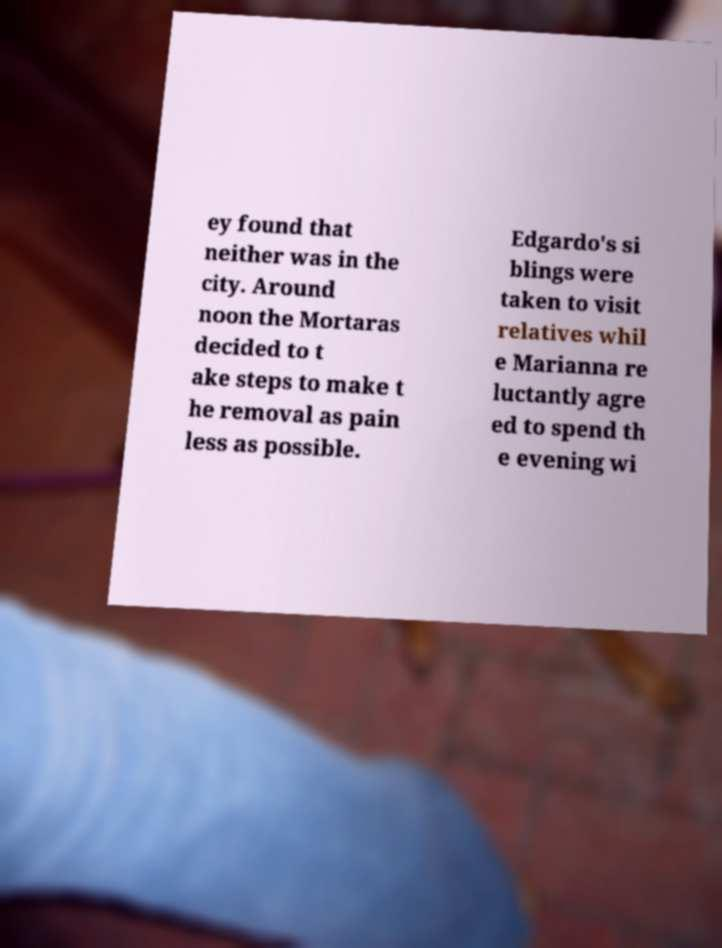Could you extract and type out the text from this image? ey found that neither was in the city. Around noon the Mortaras decided to t ake steps to make t he removal as pain less as possible. Edgardo's si blings were taken to visit relatives whil e Marianna re luctantly agre ed to spend th e evening wi 